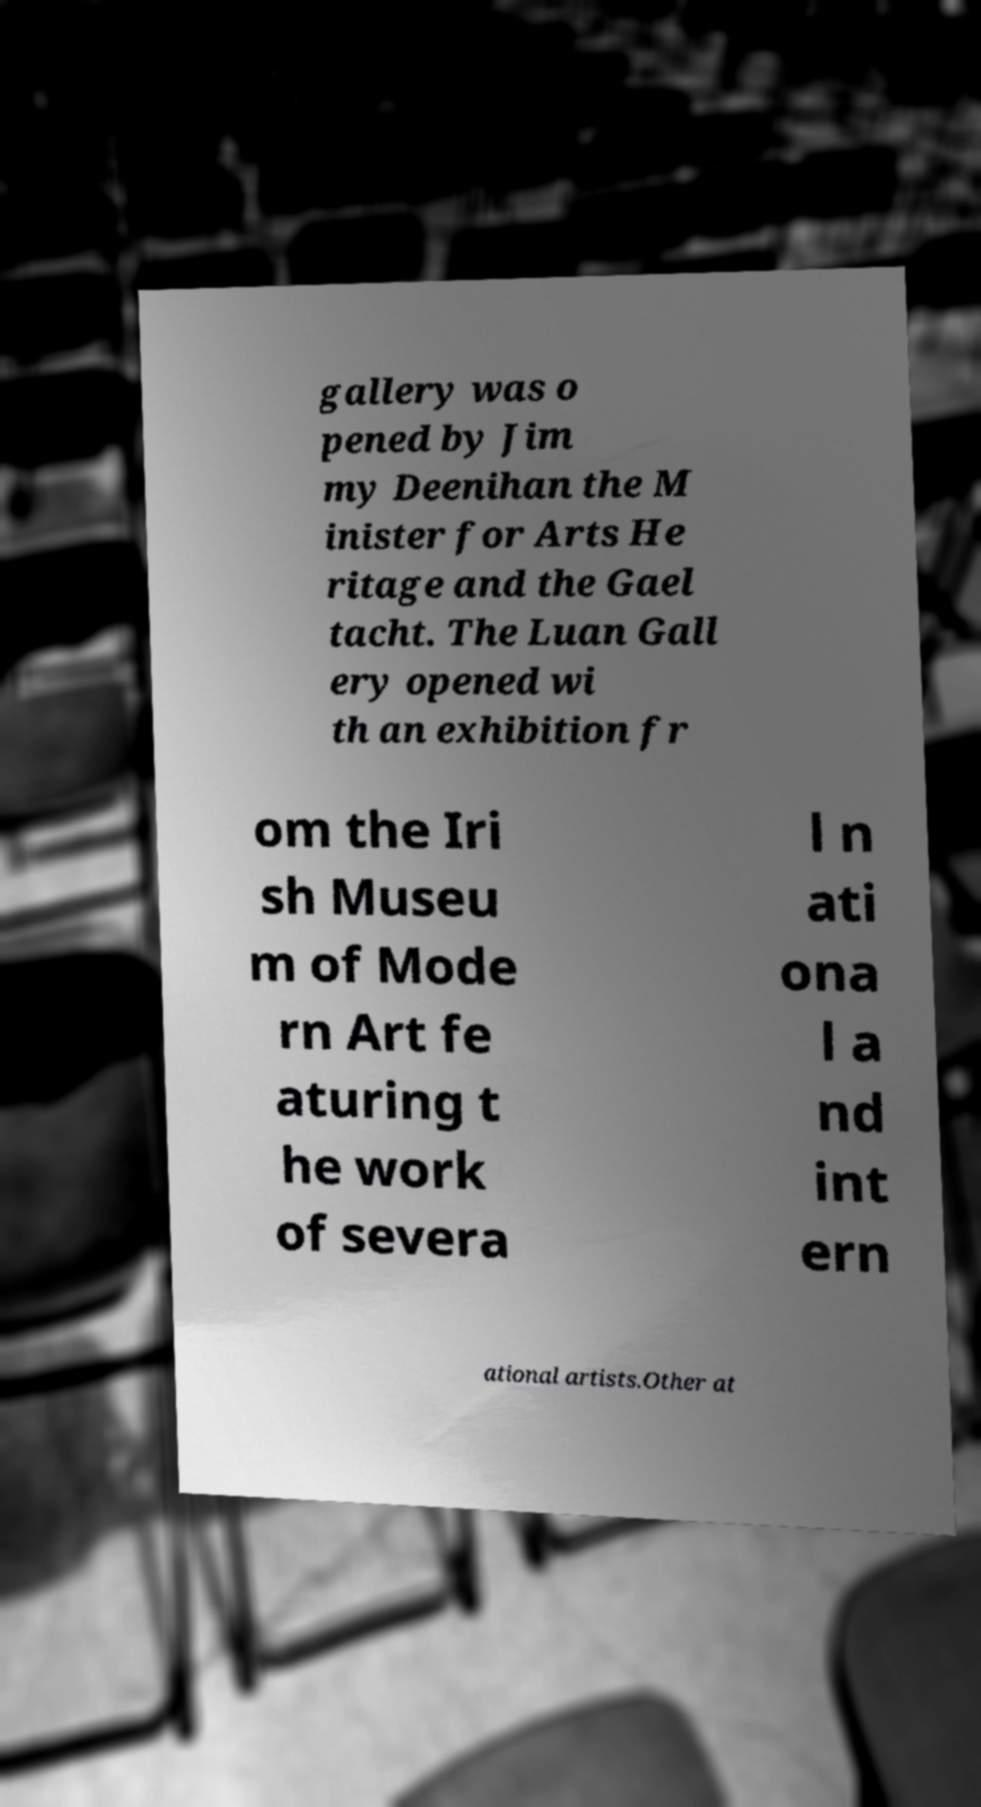Could you extract and type out the text from this image? gallery was o pened by Jim my Deenihan the M inister for Arts He ritage and the Gael tacht. The Luan Gall ery opened wi th an exhibition fr om the Iri sh Museu m of Mode rn Art fe aturing t he work of severa l n ati ona l a nd int ern ational artists.Other at 